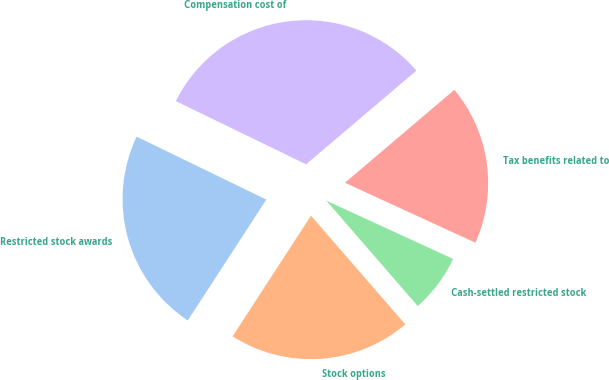Convert chart. <chart><loc_0><loc_0><loc_500><loc_500><pie_chart><fcel>Restricted stock awards<fcel>Stock options<fcel>Cash-settled restricted stock<fcel>Tax benefits related to<fcel>Compensation cost of<nl><fcel>23.02%<fcel>20.54%<fcel>6.77%<fcel>18.06%<fcel>31.6%<nl></chart> 